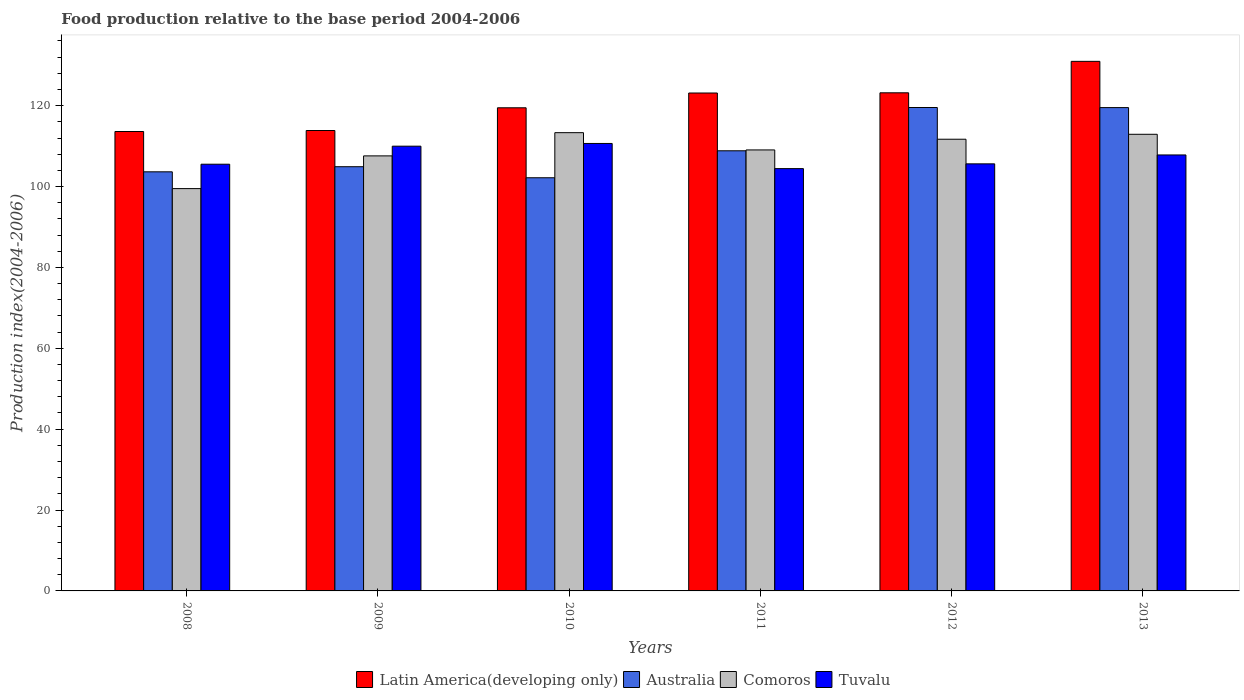How many different coloured bars are there?
Offer a terse response. 4. Are the number of bars on each tick of the X-axis equal?
Offer a very short reply. Yes. What is the label of the 5th group of bars from the left?
Make the answer very short. 2012. What is the food production index in Comoros in 2013?
Offer a terse response. 112.92. Across all years, what is the maximum food production index in Australia?
Offer a very short reply. 119.54. Across all years, what is the minimum food production index in Tuvalu?
Keep it short and to the point. 104.43. What is the total food production index in Latin America(developing only) in the graph?
Offer a very short reply. 724.19. What is the difference between the food production index in Comoros in 2008 and that in 2009?
Provide a succinct answer. -8.09. What is the difference between the food production index in Australia in 2011 and the food production index in Comoros in 2012?
Provide a short and direct response. -2.86. What is the average food production index in Comoros per year?
Offer a very short reply. 109.01. In the year 2012, what is the difference between the food production index in Comoros and food production index in Tuvalu?
Offer a terse response. 6.09. What is the ratio of the food production index in Australia in 2008 to that in 2009?
Your answer should be very brief. 0.99. Is the food production index in Australia in 2010 less than that in 2011?
Provide a short and direct response. Yes. What is the difference between the highest and the second highest food production index in Australia?
Make the answer very short. 0.02. What is the difference between the highest and the lowest food production index in Tuvalu?
Your answer should be very brief. 6.22. Is the sum of the food production index in Latin America(developing only) in 2011 and 2013 greater than the maximum food production index in Tuvalu across all years?
Provide a short and direct response. Yes. What does the 2nd bar from the left in 2012 represents?
Give a very brief answer. Australia. What does the 4th bar from the right in 2011 represents?
Your answer should be compact. Latin America(developing only). Is it the case that in every year, the sum of the food production index in Australia and food production index in Comoros is greater than the food production index in Latin America(developing only)?
Your answer should be very brief. Yes. How many bars are there?
Your response must be concise. 24. Are all the bars in the graph horizontal?
Offer a very short reply. No. How many years are there in the graph?
Your response must be concise. 6. Does the graph contain grids?
Keep it short and to the point. No. Where does the legend appear in the graph?
Provide a short and direct response. Bottom center. How many legend labels are there?
Your response must be concise. 4. How are the legend labels stacked?
Make the answer very short. Horizontal. What is the title of the graph?
Make the answer very short. Food production relative to the base period 2004-2006. Does "Bulgaria" appear as one of the legend labels in the graph?
Ensure brevity in your answer.  No. What is the label or title of the Y-axis?
Keep it short and to the point. Production index(2004-2006). What is the Production index(2004-2006) in Latin America(developing only) in 2008?
Give a very brief answer. 113.61. What is the Production index(2004-2006) in Australia in 2008?
Keep it short and to the point. 103.64. What is the Production index(2004-2006) in Comoros in 2008?
Ensure brevity in your answer.  99.49. What is the Production index(2004-2006) in Tuvalu in 2008?
Give a very brief answer. 105.52. What is the Production index(2004-2006) of Latin America(developing only) in 2009?
Give a very brief answer. 113.85. What is the Production index(2004-2006) in Australia in 2009?
Keep it short and to the point. 104.9. What is the Production index(2004-2006) in Comoros in 2009?
Provide a short and direct response. 107.58. What is the Production index(2004-2006) in Tuvalu in 2009?
Give a very brief answer. 109.98. What is the Production index(2004-2006) in Latin America(developing only) in 2010?
Keep it short and to the point. 119.47. What is the Production index(2004-2006) of Australia in 2010?
Your answer should be compact. 102.17. What is the Production index(2004-2006) in Comoros in 2010?
Your answer should be very brief. 113.32. What is the Production index(2004-2006) in Tuvalu in 2010?
Your answer should be very brief. 110.65. What is the Production index(2004-2006) of Latin America(developing only) in 2011?
Provide a short and direct response. 123.13. What is the Production index(2004-2006) of Australia in 2011?
Offer a very short reply. 108.84. What is the Production index(2004-2006) of Comoros in 2011?
Your response must be concise. 109.05. What is the Production index(2004-2006) in Tuvalu in 2011?
Provide a short and direct response. 104.43. What is the Production index(2004-2006) of Latin America(developing only) in 2012?
Offer a terse response. 123.18. What is the Production index(2004-2006) in Australia in 2012?
Your answer should be very brief. 119.54. What is the Production index(2004-2006) in Comoros in 2012?
Your answer should be compact. 111.7. What is the Production index(2004-2006) in Tuvalu in 2012?
Your answer should be very brief. 105.61. What is the Production index(2004-2006) in Latin America(developing only) in 2013?
Provide a succinct answer. 130.96. What is the Production index(2004-2006) in Australia in 2013?
Provide a succinct answer. 119.52. What is the Production index(2004-2006) of Comoros in 2013?
Provide a succinct answer. 112.92. What is the Production index(2004-2006) in Tuvalu in 2013?
Offer a very short reply. 107.81. Across all years, what is the maximum Production index(2004-2006) of Latin America(developing only)?
Your answer should be compact. 130.96. Across all years, what is the maximum Production index(2004-2006) in Australia?
Offer a terse response. 119.54. Across all years, what is the maximum Production index(2004-2006) of Comoros?
Offer a very short reply. 113.32. Across all years, what is the maximum Production index(2004-2006) in Tuvalu?
Ensure brevity in your answer.  110.65. Across all years, what is the minimum Production index(2004-2006) of Latin America(developing only)?
Provide a short and direct response. 113.61. Across all years, what is the minimum Production index(2004-2006) of Australia?
Offer a very short reply. 102.17. Across all years, what is the minimum Production index(2004-2006) of Comoros?
Keep it short and to the point. 99.49. Across all years, what is the minimum Production index(2004-2006) in Tuvalu?
Ensure brevity in your answer.  104.43. What is the total Production index(2004-2006) of Latin America(developing only) in the graph?
Provide a short and direct response. 724.19. What is the total Production index(2004-2006) of Australia in the graph?
Your response must be concise. 658.61. What is the total Production index(2004-2006) of Comoros in the graph?
Your answer should be compact. 654.06. What is the total Production index(2004-2006) in Tuvalu in the graph?
Give a very brief answer. 644. What is the difference between the Production index(2004-2006) of Latin America(developing only) in 2008 and that in 2009?
Make the answer very short. -0.25. What is the difference between the Production index(2004-2006) in Australia in 2008 and that in 2009?
Provide a short and direct response. -1.26. What is the difference between the Production index(2004-2006) of Comoros in 2008 and that in 2009?
Give a very brief answer. -8.09. What is the difference between the Production index(2004-2006) of Tuvalu in 2008 and that in 2009?
Keep it short and to the point. -4.46. What is the difference between the Production index(2004-2006) of Latin America(developing only) in 2008 and that in 2010?
Offer a very short reply. -5.86. What is the difference between the Production index(2004-2006) in Australia in 2008 and that in 2010?
Provide a short and direct response. 1.47. What is the difference between the Production index(2004-2006) in Comoros in 2008 and that in 2010?
Your response must be concise. -13.83. What is the difference between the Production index(2004-2006) in Tuvalu in 2008 and that in 2010?
Make the answer very short. -5.13. What is the difference between the Production index(2004-2006) of Latin America(developing only) in 2008 and that in 2011?
Your response must be concise. -9.52. What is the difference between the Production index(2004-2006) of Australia in 2008 and that in 2011?
Provide a short and direct response. -5.2. What is the difference between the Production index(2004-2006) of Comoros in 2008 and that in 2011?
Keep it short and to the point. -9.56. What is the difference between the Production index(2004-2006) in Tuvalu in 2008 and that in 2011?
Keep it short and to the point. 1.09. What is the difference between the Production index(2004-2006) in Latin America(developing only) in 2008 and that in 2012?
Your answer should be compact. -9.57. What is the difference between the Production index(2004-2006) of Australia in 2008 and that in 2012?
Provide a short and direct response. -15.9. What is the difference between the Production index(2004-2006) in Comoros in 2008 and that in 2012?
Your response must be concise. -12.21. What is the difference between the Production index(2004-2006) in Tuvalu in 2008 and that in 2012?
Your answer should be compact. -0.09. What is the difference between the Production index(2004-2006) in Latin America(developing only) in 2008 and that in 2013?
Offer a very short reply. -17.35. What is the difference between the Production index(2004-2006) of Australia in 2008 and that in 2013?
Give a very brief answer. -15.88. What is the difference between the Production index(2004-2006) of Comoros in 2008 and that in 2013?
Offer a terse response. -13.43. What is the difference between the Production index(2004-2006) in Tuvalu in 2008 and that in 2013?
Ensure brevity in your answer.  -2.29. What is the difference between the Production index(2004-2006) of Latin America(developing only) in 2009 and that in 2010?
Offer a terse response. -5.62. What is the difference between the Production index(2004-2006) in Australia in 2009 and that in 2010?
Make the answer very short. 2.73. What is the difference between the Production index(2004-2006) in Comoros in 2009 and that in 2010?
Your response must be concise. -5.74. What is the difference between the Production index(2004-2006) in Tuvalu in 2009 and that in 2010?
Offer a very short reply. -0.67. What is the difference between the Production index(2004-2006) of Latin America(developing only) in 2009 and that in 2011?
Keep it short and to the point. -9.27. What is the difference between the Production index(2004-2006) in Australia in 2009 and that in 2011?
Give a very brief answer. -3.94. What is the difference between the Production index(2004-2006) in Comoros in 2009 and that in 2011?
Your answer should be very brief. -1.47. What is the difference between the Production index(2004-2006) in Tuvalu in 2009 and that in 2011?
Give a very brief answer. 5.55. What is the difference between the Production index(2004-2006) of Latin America(developing only) in 2009 and that in 2012?
Offer a very short reply. -9.32. What is the difference between the Production index(2004-2006) of Australia in 2009 and that in 2012?
Keep it short and to the point. -14.64. What is the difference between the Production index(2004-2006) in Comoros in 2009 and that in 2012?
Offer a terse response. -4.12. What is the difference between the Production index(2004-2006) in Tuvalu in 2009 and that in 2012?
Provide a short and direct response. 4.37. What is the difference between the Production index(2004-2006) of Latin America(developing only) in 2009 and that in 2013?
Keep it short and to the point. -17.1. What is the difference between the Production index(2004-2006) in Australia in 2009 and that in 2013?
Offer a terse response. -14.62. What is the difference between the Production index(2004-2006) in Comoros in 2009 and that in 2013?
Offer a very short reply. -5.34. What is the difference between the Production index(2004-2006) of Tuvalu in 2009 and that in 2013?
Keep it short and to the point. 2.17. What is the difference between the Production index(2004-2006) of Latin America(developing only) in 2010 and that in 2011?
Your answer should be compact. -3.66. What is the difference between the Production index(2004-2006) in Australia in 2010 and that in 2011?
Provide a succinct answer. -6.67. What is the difference between the Production index(2004-2006) in Comoros in 2010 and that in 2011?
Give a very brief answer. 4.27. What is the difference between the Production index(2004-2006) in Tuvalu in 2010 and that in 2011?
Offer a very short reply. 6.22. What is the difference between the Production index(2004-2006) of Latin America(developing only) in 2010 and that in 2012?
Your answer should be very brief. -3.71. What is the difference between the Production index(2004-2006) in Australia in 2010 and that in 2012?
Offer a terse response. -17.37. What is the difference between the Production index(2004-2006) in Comoros in 2010 and that in 2012?
Your response must be concise. 1.62. What is the difference between the Production index(2004-2006) in Tuvalu in 2010 and that in 2012?
Keep it short and to the point. 5.04. What is the difference between the Production index(2004-2006) of Latin America(developing only) in 2010 and that in 2013?
Provide a succinct answer. -11.48. What is the difference between the Production index(2004-2006) of Australia in 2010 and that in 2013?
Ensure brevity in your answer.  -17.35. What is the difference between the Production index(2004-2006) of Comoros in 2010 and that in 2013?
Make the answer very short. 0.4. What is the difference between the Production index(2004-2006) of Tuvalu in 2010 and that in 2013?
Your response must be concise. 2.84. What is the difference between the Production index(2004-2006) in Latin America(developing only) in 2011 and that in 2012?
Offer a terse response. -0.05. What is the difference between the Production index(2004-2006) of Australia in 2011 and that in 2012?
Your answer should be very brief. -10.7. What is the difference between the Production index(2004-2006) of Comoros in 2011 and that in 2012?
Ensure brevity in your answer.  -2.65. What is the difference between the Production index(2004-2006) in Tuvalu in 2011 and that in 2012?
Keep it short and to the point. -1.18. What is the difference between the Production index(2004-2006) in Latin America(developing only) in 2011 and that in 2013?
Ensure brevity in your answer.  -7.83. What is the difference between the Production index(2004-2006) in Australia in 2011 and that in 2013?
Your answer should be compact. -10.68. What is the difference between the Production index(2004-2006) in Comoros in 2011 and that in 2013?
Offer a terse response. -3.87. What is the difference between the Production index(2004-2006) in Tuvalu in 2011 and that in 2013?
Provide a succinct answer. -3.38. What is the difference between the Production index(2004-2006) of Latin America(developing only) in 2012 and that in 2013?
Your response must be concise. -7.78. What is the difference between the Production index(2004-2006) in Australia in 2012 and that in 2013?
Keep it short and to the point. 0.02. What is the difference between the Production index(2004-2006) in Comoros in 2012 and that in 2013?
Make the answer very short. -1.22. What is the difference between the Production index(2004-2006) in Latin America(developing only) in 2008 and the Production index(2004-2006) in Australia in 2009?
Provide a short and direct response. 8.71. What is the difference between the Production index(2004-2006) of Latin America(developing only) in 2008 and the Production index(2004-2006) of Comoros in 2009?
Offer a very short reply. 6.03. What is the difference between the Production index(2004-2006) in Latin America(developing only) in 2008 and the Production index(2004-2006) in Tuvalu in 2009?
Keep it short and to the point. 3.63. What is the difference between the Production index(2004-2006) in Australia in 2008 and the Production index(2004-2006) in Comoros in 2009?
Provide a short and direct response. -3.94. What is the difference between the Production index(2004-2006) of Australia in 2008 and the Production index(2004-2006) of Tuvalu in 2009?
Your answer should be very brief. -6.34. What is the difference between the Production index(2004-2006) in Comoros in 2008 and the Production index(2004-2006) in Tuvalu in 2009?
Your answer should be very brief. -10.49. What is the difference between the Production index(2004-2006) of Latin America(developing only) in 2008 and the Production index(2004-2006) of Australia in 2010?
Give a very brief answer. 11.44. What is the difference between the Production index(2004-2006) of Latin America(developing only) in 2008 and the Production index(2004-2006) of Comoros in 2010?
Offer a terse response. 0.29. What is the difference between the Production index(2004-2006) of Latin America(developing only) in 2008 and the Production index(2004-2006) of Tuvalu in 2010?
Offer a terse response. 2.96. What is the difference between the Production index(2004-2006) of Australia in 2008 and the Production index(2004-2006) of Comoros in 2010?
Provide a succinct answer. -9.68. What is the difference between the Production index(2004-2006) of Australia in 2008 and the Production index(2004-2006) of Tuvalu in 2010?
Your answer should be very brief. -7.01. What is the difference between the Production index(2004-2006) in Comoros in 2008 and the Production index(2004-2006) in Tuvalu in 2010?
Offer a terse response. -11.16. What is the difference between the Production index(2004-2006) of Latin America(developing only) in 2008 and the Production index(2004-2006) of Australia in 2011?
Your answer should be very brief. 4.77. What is the difference between the Production index(2004-2006) in Latin America(developing only) in 2008 and the Production index(2004-2006) in Comoros in 2011?
Give a very brief answer. 4.56. What is the difference between the Production index(2004-2006) in Latin America(developing only) in 2008 and the Production index(2004-2006) in Tuvalu in 2011?
Your response must be concise. 9.18. What is the difference between the Production index(2004-2006) of Australia in 2008 and the Production index(2004-2006) of Comoros in 2011?
Give a very brief answer. -5.41. What is the difference between the Production index(2004-2006) of Australia in 2008 and the Production index(2004-2006) of Tuvalu in 2011?
Your response must be concise. -0.79. What is the difference between the Production index(2004-2006) in Comoros in 2008 and the Production index(2004-2006) in Tuvalu in 2011?
Offer a very short reply. -4.94. What is the difference between the Production index(2004-2006) in Latin America(developing only) in 2008 and the Production index(2004-2006) in Australia in 2012?
Your answer should be very brief. -5.93. What is the difference between the Production index(2004-2006) of Latin America(developing only) in 2008 and the Production index(2004-2006) of Comoros in 2012?
Your answer should be very brief. 1.91. What is the difference between the Production index(2004-2006) of Latin America(developing only) in 2008 and the Production index(2004-2006) of Tuvalu in 2012?
Offer a terse response. 8. What is the difference between the Production index(2004-2006) in Australia in 2008 and the Production index(2004-2006) in Comoros in 2012?
Provide a succinct answer. -8.06. What is the difference between the Production index(2004-2006) of Australia in 2008 and the Production index(2004-2006) of Tuvalu in 2012?
Your answer should be compact. -1.97. What is the difference between the Production index(2004-2006) in Comoros in 2008 and the Production index(2004-2006) in Tuvalu in 2012?
Keep it short and to the point. -6.12. What is the difference between the Production index(2004-2006) in Latin America(developing only) in 2008 and the Production index(2004-2006) in Australia in 2013?
Your answer should be very brief. -5.91. What is the difference between the Production index(2004-2006) of Latin America(developing only) in 2008 and the Production index(2004-2006) of Comoros in 2013?
Your response must be concise. 0.69. What is the difference between the Production index(2004-2006) of Latin America(developing only) in 2008 and the Production index(2004-2006) of Tuvalu in 2013?
Offer a very short reply. 5.8. What is the difference between the Production index(2004-2006) of Australia in 2008 and the Production index(2004-2006) of Comoros in 2013?
Keep it short and to the point. -9.28. What is the difference between the Production index(2004-2006) in Australia in 2008 and the Production index(2004-2006) in Tuvalu in 2013?
Provide a succinct answer. -4.17. What is the difference between the Production index(2004-2006) in Comoros in 2008 and the Production index(2004-2006) in Tuvalu in 2013?
Your answer should be compact. -8.32. What is the difference between the Production index(2004-2006) of Latin America(developing only) in 2009 and the Production index(2004-2006) of Australia in 2010?
Your response must be concise. 11.68. What is the difference between the Production index(2004-2006) of Latin America(developing only) in 2009 and the Production index(2004-2006) of Comoros in 2010?
Your answer should be very brief. 0.53. What is the difference between the Production index(2004-2006) of Latin America(developing only) in 2009 and the Production index(2004-2006) of Tuvalu in 2010?
Make the answer very short. 3.2. What is the difference between the Production index(2004-2006) of Australia in 2009 and the Production index(2004-2006) of Comoros in 2010?
Offer a very short reply. -8.42. What is the difference between the Production index(2004-2006) in Australia in 2009 and the Production index(2004-2006) in Tuvalu in 2010?
Give a very brief answer. -5.75. What is the difference between the Production index(2004-2006) of Comoros in 2009 and the Production index(2004-2006) of Tuvalu in 2010?
Your response must be concise. -3.07. What is the difference between the Production index(2004-2006) in Latin America(developing only) in 2009 and the Production index(2004-2006) in Australia in 2011?
Give a very brief answer. 5.01. What is the difference between the Production index(2004-2006) of Latin America(developing only) in 2009 and the Production index(2004-2006) of Comoros in 2011?
Your response must be concise. 4.8. What is the difference between the Production index(2004-2006) of Latin America(developing only) in 2009 and the Production index(2004-2006) of Tuvalu in 2011?
Offer a terse response. 9.42. What is the difference between the Production index(2004-2006) of Australia in 2009 and the Production index(2004-2006) of Comoros in 2011?
Give a very brief answer. -4.15. What is the difference between the Production index(2004-2006) in Australia in 2009 and the Production index(2004-2006) in Tuvalu in 2011?
Your response must be concise. 0.47. What is the difference between the Production index(2004-2006) in Comoros in 2009 and the Production index(2004-2006) in Tuvalu in 2011?
Make the answer very short. 3.15. What is the difference between the Production index(2004-2006) of Latin America(developing only) in 2009 and the Production index(2004-2006) of Australia in 2012?
Keep it short and to the point. -5.69. What is the difference between the Production index(2004-2006) in Latin America(developing only) in 2009 and the Production index(2004-2006) in Comoros in 2012?
Your answer should be very brief. 2.15. What is the difference between the Production index(2004-2006) of Latin America(developing only) in 2009 and the Production index(2004-2006) of Tuvalu in 2012?
Give a very brief answer. 8.24. What is the difference between the Production index(2004-2006) in Australia in 2009 and the Production index(2004-2006) in Tuvalu in 2012?
Your response must be concise. -0.71. What is the difference between the Production index(2004-2006) in Comoros in 2009 and the Production index(2004-2006) in Tuvalu in 2012?
Provide a short and direct response. 1.97. What is the difference between the Production index(2004-2006) of Latin America(developing only) in 2009 and the Production index(2004-2006) of Australia in 2013?
Offer a very short reply. -5.67. What is the difference between the Production index(2004-2006) of Latin America(developing only) in 2009 and the Production index(2004-2006) of Comoros in 2013?
Your answer should be very brief. 0.93. What is the difference between the Production index(2004-2006) of Latin America(developing only) in 2009 and the Production index(2004-2006) of Tuvalu in 2013?
Keep it short and to the point. 6.04. What is the difference between the Production index(2004-2006) of Australia in 2009 and the Production index(2004-2006) of Comoros in 2013?
Provide a succinct answer. -8.02. What is the difference between the Production index(2004-2006) in Australia in 2009 and the Production index(2004-2006) in Tuvalu in 2013?
Your answer should be compact. -2.91. What is the difference between the Production index(2004-2006) of Comoros in 2009 and the Production index(2004-2006) of Tuvalu in 2013?
Your answer should be very brief. -0.23. What is the difference between the Production index(2004-2006) in Latin America(developing only) in 2010 and the Production index(2004-2006) in Australia in 2011?
Your answer should be very brief. 10.63. What is the difference between the Production index(2004-2006) of Latin America(developing only) in 2010 and the Production index(2004-2006) of Comoros in 2011?
Your answer should be very brief. 10.42. What is the difference between the Production index(2004-2006) of Latin America(developing only) in 2010 and the Production index(2004-2006) of Tuvalu in 2011?
Offer a terse response. 15.04. What is the difference between the Production index(2004-2006) of Australia in 2010 and the Production index(2004-2006) of Comoros in 2011?
Provide a short and direct response. -6.88. What is the difference between the Production index(2004-2006) of Australia in 2010 and the Production index(2004-2006) of Tuvalu in 2011?
Provide a succinct answer. -2.26. What is the difference between the Production index(2004-2006) of Comoros in 2010 and the Production index(2004-2006) of Tuvalu in 2011?
Offer a very short reply. 8.89. What is the difference between the Production index(2004-2006) in Latin America(developing only) in 2010 and the Production index(2004-2006) in Australia in 2012?
Give a very brief answer. -0.07. What is the difference between the Production index(2004-2006) of Latin America(developing only) in 2010 and the Production index(2004-2006) of Comoros in 2012?
Provide a short and direct response. 7.77. What is the difference between the Production index(2004-2006) of Latin America(developing only) in 2010 and the Production index(2004-2006) of Tuvalu in 2012?
Offer a very short reply. 13.86. What is the difference between the Production index(2004-2006) of Australia in 2010 and the Production index(2004-2006) of Comoros in 2012?
Your response must be concise. -9.53. What is the difference between the Production index(2004-2006) of Australia in 2010 and the Production index(2004-2006) of Tuvalu in 2012?
Make the answer very short. -3.44. What is the difference between the Production index(2004-2006) in Comoros in 2010 and the Production index(2004-2006) in Tuvalu in 2012?
Ensure brevity in your answer.  7.71. What is the difference between the Production index(2004-2006) of Latin America(developing only) in 2010 and the Production index(2004-2006) of Australia in 2013?
Offer a very short reply. -0.05. What is the difference between the Production index(2004-2006) of Latin America(developing only) in 2010 and the Production index(2004-2006) of Comoros in 2013?
Keep it short and to the point. 6.55. What is the difference between the Production index(2004-2006) of Latin America(developing only) in 2010 and the Production index(2004-2006) of Tuvalu in 2013?
Give a very brief answer. 11.66. What is the difference between the Production index(2004-2006) of Australia in 2010 and the Production index(2004-2006) of Comoros in 2013?
Offer a very short reply. -10.75. What is the difference between the Production index(2004-2006) in Australia in 2010 and the Production index(2004-2006) in Tuvalu in 2013?
Your answer should be very brief. -5.64. What is the difference between the Production index(2004-2006) of Comoros in 2010 and the Production index(2004-2006) of Tuvalu in 2013?
Your response must be concise. 5.51. What is the difference between the Production index(2004-2006) in Latin America(developing only) in 2011 and the Production index(2004-2006) in Australia in 2012?
Your response must be concise. 3.59. What is the difference between the Production index(2004-2006) of Latin America(developing only) in 2011 and the Production index(2004-2006) of Comoros in 2012?
Offer a very short reply. 11.43. What is the difference between the Production index(2004-2006) in Latin America(developing only) in 2011 and the Production index(2004-2006) in Tuvalu in 2012?
Your answer should be compact. 17.52. What is the difference between the Production index(2004-2006) of Australia in 2011 and the Production index(2004-2006) of Comoros in 2012?
Make the answer very short. -2.86. What is the difference between the Production index(2004-2006) in Australia in 2011 and the Production index(2004-2006) in Tuvalu in 2012?
Ensure brevity in your answer.  3.23. What is the difference between the Production index(2004-2006) of Comoros in 2011 and the Production index(2004-2006) of Tuvalu in 2012?
Make the answer very short. 3.44. What is the difference between the Production index(2004-2006) of Latin America(developing only) in 2011 and the Production index(2004-2006) of Australia in 2013?
Your response must be concise. 3.61. What is the difference between the Production index(2004-2006) of Latin America(developing only) in 2011 and the Production index(2004-2006) of Comoros in 2013?
Provide a succinct answer. 10.21. What is the difference between the Production index(2004-2006) of Latin America(developing only) in 2011 and the Production index(2004-2006) of Tuvalu in 2013?
Ensure brevity in your answer.  15.32. What is the difference between the Production index(2004-2006) of Australia in 2011 and the Production index(2004-2006) of Comoros in 2013?
Provide a succinct answer. -4.08. What is the difference between the Production index(2004-2006) in Comoros in 2011 and the Production index(2004-2006) in Tuvalu in 2013?
Give a very brief answer. 1.24. What is the difference between the Production index(2004-2006) in Latin America(developing only) in 2012 and the Production index(2004-2006) in Australia in 2013?
Your answer should be very brief. 3.66. What is the difference between the Production index(2004-2006) in Latin America(developing only) in 2012 and the Production index(2004-2006) in Comoros in 2013?
Ensure brevity in your answer.  10.26. What is the difference between the Production index(2004-2006) in Latin America(developing only) in 2012 and the Production index(2004-2006) in Tuvalu in 2013?
Provide a succinct answer. 15.37. What is the difference between the Production index(2004-2006) in Australia in 2012 and the Production index(2004-2006) in Comoros in 2013?
Provide a succinct answer. 6.62. What is the difference between the Production index(2004-2006) of Australia in 2012 and the Production index(2004-2006) of Tuvalu in 2013?
Offer a terse response. 11.73. What is the difference between the Production index(2004-2006) in Comoros in 2012 and the Production index(2004-2006) in Tuvalu in 2013?
Provide a short and direct response. 3.89. What is the average Production index(2004-2006) in Latin America(developing only) per year?
Provide a succinct answer. 120.7. What is the average Production index(2004-2006) in Australia per year?
Make the answer very short. 109.77. What is the average Production index(2004-2006) in Comoros per year?
Keep it short and to the point. 109.01. What is the average Production index(2004-2006) of Tuvalu per year?
Your answer should be very brief. 107.33. In the year 2008, what is the difference between the Production index(2004-2006) in Latin America(developing only) and Production index(2004-2006) in Australia?
Your answer should be compact. 9.97. In the year 2008, what is the difference between the Production index(2004-2006) in Latin America(developing only) and Production index(2004-2006) in Comoros?
Offer a terse response. 14.12. In the year 2008, what is the difference between the Production index(2004-2006) of Latin America(developing only) and Production index(2004-2006) of Tuvalu?
Make the answer very short. 8.09. In the year 2008, what is the difference between the Production index(2004-2006) of Australia and Production index(2004-2006) of Comoros?
Ensure brevity in your answer.  4.15. In the year 2008, what is the difference between the Production index(2004-2006) of Australia and Production index(2004-2006) of Tuvalu?
Provide a short and direct response. -1.88. In the year 2008, what is the difference between the Production index(2004-2006) in Comoros and Production index(2004-2006) in Tuvalu?
Offer a very short reply. -6.03. In the year 2009, what is the difference between the Production index(2004-2006) of Latin America(developing only) and Production index(2004-2006) of Australia?
Provide a short and direct response. 8.95. In the year 2009, what is the difference between the Production index(2004-2006) of Latin America(developing only) and Production index(2004-2006) of Comoros?
Ensure brevity in your answer.  6.27. In the year 2009, what is the difference between the Production index(2004-2006) of Latin America(developing only) and Production index(2004-2006) of Tuvalu?
Give a very brief answer. 3.87. In the year 2009, what is the difference between the Production index(2004-2006) in Australia and Production index(2004-2006) in Comoros?
Offer a very short reply. -2.68. In the year 2009, what is the difference between the Production index(2004-2006) of Australia and Production index(2004-2006) of Tuvalu?
Make the answer very short. -5.08. In the year 2010, what is the difference between the Production index(2004-2006) in Latin America(developing only) and Production index(2004-2006) in Australia?
Offer a very short reply. 17.3. In the year 2010, what is the difference between the Production index(2004-2006) of Latin America(developing only) and Production index(2004-2006) of Comoros?
Provide a short and direct response. 6.15. In the year 2010, what is the difference between the Production index(2004-2006) in Latin America(developing only) and Production index(2004-2006) in Tuvalu?
Provide a short and direct response. 8.82. In the year 2010, what is the difference between the Production index(2004-2006) in Australia and Production index(2004-2006) in Comoros?
Provide a short and direct response. -11.15. In the year 2010, what is the difference between the Production index(2004-2006) in Australia and Production index(2004-2006) in Tuvalu?
Provide a short and direct response. -8.48. In the year 2010, what is the difference between the Production index(2004-2006) in Comoros and Production index(2004-2006) in Tuvalu?
Keep it short and to the point. 2.67. In the year 2011, what is the difference between the Production index(2004-2006) in Latin America(developing only) and Production index(2004-2006) in Australia?
Provide a succinct answer. 14.29. In the year 2011, what is the difference between the Production index(2004-2006) in Latin America(developing only) and Production index(2004-2006) in Comoros?
Provide a succinct answer. 14.08. In the year 2011, what is the difference between the Production index(2004-2006) of Latin America(developing only) and Production index(2004-2006) of Tuvalu?
Offer a terse response. 18.7. In the year 2011, what is the difference between the Production index(2004-2006) of Australia and Production index(2004-2006) of Comoros?
Ensure brevity in your answer.  -0.21. In the year 2011, what is the difference between the Production index(2004-2006) of Australia and Production index(2004-2006) of Tuvalu?
Make the answer very short. 4.41. In the year 2011, what is the difference between the Production index(2004-2006) of Comoros and Production index(2004-2006) of Tuvalu?
Offer a terse response. 4.62. In the year 2012, what is the difference between the Production index(2004-2006) in Latin America(developing only) and Production index(2004-2006) in Australia?
Make the answer very short. 3.64. In the year 2012, what is the difference between the Production index(2004-2006) of Latin America(developing only) and Production index(2004-2006) of Comoros?
Give a very brief answer. 11.48. In the year 2012, what is the difference between the Production index(2004-2006) of Latin America(developing only) and Production index(2004-2006) of Tuvalu?
Keep it short and to the point. 17.57. In the year 2012, what is the difference between the Production index(2004-2006) of Australia and Production index(2004-2006) of Comoros?
Your answer should be compact. 7.84. In the year 2012, what is the difference between the Production index(2004-2006) in Australia and Production index(2004-2006) in Tuvalu?
Offer a terse response. 13.93. In the year 2012, what is the difference between the Production index(2004-2006) of Comoros and Production index(2004-2006) of Tuvalu?
Make the answer very short. 6.09. In the year 2013, what is the difference between the Production index(2004-2006) of Latin America(developing only) and Production index(2004-2006) of Australia?
Offer a terse response. 11.44. In the year 2013, what is the difference between the Production index(2004-2006) of Latin America(developing only) and Production index(2004-2006) of Comoros?
Provide a short and direct response. 18.04. In the year 2013, what is the difference between the Production index(2004-2006) in Latin America(developing only) and Production index(2004-2006) in Tuvalu?
Your answer should be very brief. 23.15. In the year 2013, what is the difference between the Production index(2004-2006) in Australia and Production index(2004-2006) in Comoros?
Give a very brief answer. 6.6. In the year 2013, what is the difference between the Production index(2004-2006) in Australia and Production index(2004-2006) in Tuvalu?
Your answer should be very brief. 11.71. In the year 2013, what is the difference between the Production index(2004-2006) of Comoros and Production index(2004-2006) of Tuvalu?
Give a very brief answer. 5.11. What is the ratio of the Production index(2004-2006) in Latin America(developing only) in 2008 to that in 2009?
Your response must be concise. 1. What is the ratio of the Production index(2004-2006) in Comoros in 2008 to that in 2009?
Your answer should be very brief. 0.92. What is the ratio of the Production index(2004-2006) in Tuvalu in 2008 to that in 2009?
Your answer should be very brief. 0.96. What is the ratio of the Production index(2004-2006) of Latin America(developing only) in 2008 to that in 2010?
Provide a succinct answer. 0.95. What is the ratio of the Production index(2004-2006) of Australia in 2008 to that in 2010?
Your answer should be very brief. 1.01. What is the ratio of the Production index(2004-2006) of Comoros in 2008 to that in 2010?
Your response must be concise. 0.88. What is the ratio of the Production index(2004-2006) in Tuvalu in 2008 to that in 2010?
Provide a short and direct response. 0.95. What is the ratio of the Production index(2004-2006) in Latin America(developing only) in 2008 to that in 2011?
Offer a terse response. 0.92. What is the ratio of the Production index(2004-2006) in Australia in 2008 to that in 2011?
Keep it short and to the point. 0.95. What is the ratio of the Production index(2004-2006) in Comoros in 2008 to that in 2011?
Offer a terse response. 0.91. What is the ratio of the Production index(2004-2006) of Tuvalu in 2008 to that in 2011?
Keep it short and to the point. 1.01. What is the ratio of the Production index(2004-2006) of Latin America(developing only) in 2008 to that in 2012?
Offer a very short reply. 0.92. What is the ratio of the Production index(2004-2006) of Australia in 2008 to that in 2012?
Provide a succinct answer. 0.87. What is the ratio of the Production index(2004-2006) in Comoros in 2008 to that in 2012?
Provide a short and direct response. 0.89. What is the ratio of the Production index(2004-2006) in Latin America(developing only) in 2008 to that in 2013?
Your answer should be very brief. 0.87. What is the ratio of the Production index(2004-2006) in Australia in 2008 to that in 2013?
Offer a very short reply. 0.87. What is the ratio of the Production index(2004-2006) in Comoros in 2008 to that in 2013?
Provide a short and direct response. 0.88. What is the ratio of the Production index(2004-2006) in Tuvalu in 2008 to that in 2013?
Make the answer very short. 0.98. What is the ratio of the Production index(2004-2006) in Latin America(developing only) in 2009 to that in 2010?
Offer a very short reply. 0.95. What is the ratio of the Production index(2004-2006) of Australia in 2009 to that in 2010?
Your answer should be very brief. 1.03. What is the ratio of the Production index(2004-2006) of Comoros in 2009 to that in 2010?
Your answer should be compact. 0.95. What is the ratio of the Production index(2004-2006) of Latin America(developing only) in 2009 to that in 2011?
Offer a terse response. 0.92. What is the ratio of the Production index(2004-2006) of Australia in 2009 to that in 2011?
Give a very brief answer. 0.96. What is the ratio of the Production index(2004-2006) of Comoros in 2009 to that in 2011?
Provide a short and direct response. 0.99. What is the ratio of the Production index(2004-2006) in Tuvalu in 2009 to that in 2011?
Ensure brevity in your answer.  1.05. What is the ratio of the Production index(2004-2006) of Latin America(developing only) in 2009 to that in 2012?
Offer a terse response. 0.92. What is the ratio of the Production index(2004-2006) of Australia in 2009 to that in 2012?
Your response must be concise. 0.88. What is the ratio of the Production index(2004-2006) in Comoros in 2009 to that in 2012?
Ensure brevity in your answer.  0.96. What is the ratio of the Production index(2004-2006) in Tuvalu in 2009 to that in 2012?
Make the answer very short. 1.04. What is the ratio of the Production index(2004-2006) of Latin America(developing only) in 2009 to that in 2013?
Your response must be concise. 0.87. What is the ratio of the Production index(2004-2006) of Australia in 2009 to that in 2013?
Make the answer very short. 0.88. What is the ratio of the Production index(2004-2006) of Comoros in 2009 to that in 2013?
Your answer should be compact. 0.95. What is the ratio of the Production index(2004-2006) in Tuvalu in 2009 to that in 2013?
Keep it short and to the point. 1.02. What is the ratio of the Production index(2004-2006) in Latin America(developing only) in 2010 to that in 2011?
Your response must be concise. 0.97. What is the ratio of the Production index(2004-2006) in Australia in 2010 to that in 2011?
Your answer should be compact. 0.94. What is the ratio of the Production index(2004-2006) in Comoros in 2010 to that in 2011?
Offer a very short reply. 1.04. What is the ratio of the Production index(2004-2006) of Tuvalu in 2010 to that in 2011?
Provide a short and direct response. 1.06. What is the ratio of the Production index(2004-2006) in Latin America(developing only) in 2010 to that in 2012?
Your answer should be very brief. 0.97. What is the ratio of the Production index(2004-2006) of Australia in 2010 to that in 2012?
Give a very brief answer. 0.85. What is the ratio of the Production index(2004-2006) of Comoros in 2010 to that in 2012?
Your response must be concise. 1.01. What is the ratio of the Production index(2004-2006) in Tuvalu in 2010 to that in 2012?
Offer a terse response. 1.05. What is the ratio of the Production index(2004-2006) of Latin America(developing only) in 2010 to that in 2013?
Your answer should be compact. 0.91. What is the ratio of the Production index(2004-2006) of Australia in 2010 to that in 2013?
Your answer should be compact. 0.85. What is the ratio of the Production index(2004-2006) in Tuvalu in 2010 to that in 2013?
Give a very brief answer. 1.03. What is the ratio of the Production index(2004-2006) of Latin America(developing only) in 2011 to that in 2012?
Provide a succinct answer. 1. What is the ratio of the Production index(2004-2006) in Australia in 2011 to that in 2012?
Provide a short and direct response. 0.91. What is the ratio of the Production index(2004-2006) in Comoros in 2011 to that in 2012?
Your answer should be very brief. 0.98. What is the ratio of the Production index(2004-2006) in Latin America(developing only) in 2011 to that in 2013?
Ensure brevity in your answer.  0.94. What is the ratio of the Production index(2004-2006) of Australia in 2011 to that in 2013?
Make the answer very short. 0.91. What is the ratio of the Production index(2004-2006) in Comoros in 2011 to that in 2013?
Ensure brevity in your answer.  0.97. What is the ratio of the Production index(2004-2006) of Tuvalu in 2011 to that in 2013?
Ensure brevity in your answer.  0.97. What is the ratio of the Production index(2004-2006) in Latin America(developing only) in 2012 to that in 2013?
Keep it short and to the point. 0.94. What is the ratio of the Production index(2004-2006) of Comoros in 2012 to that in 2013?
Your response must be concise. 0.99. What is the ratio of the Production index(2004-2006) of Tuvalu in 2012 to that in 2013?
Your response must be concise. 0.98. What is the difference between the highest and the second highest Production index(2004-2006) in Latin America(developing only)?
Your response must be concise. 7.78. What is the difference between the highest and the second highest Production index(2004-2006) of Tuvalu?
Provide a succinct answer. 0.67. What is the difference between the highest and the lowest Production index(2004-2006) of Latin America(developing only)?
Provide a succinct answer. 17.35. What is the difference between the highest and the lowest Production index(2004-2006) in Australia?
Keep it short and to the point. 17.37. What is the difference between the highest and the lowest Production index(2004-2006) of Comoros?
Keep it short and to the point. 13.83. What is the difference between the highest and the lowest Production index(2004-2006) in Tuvalu?
Make the answer very short. 6.22. 